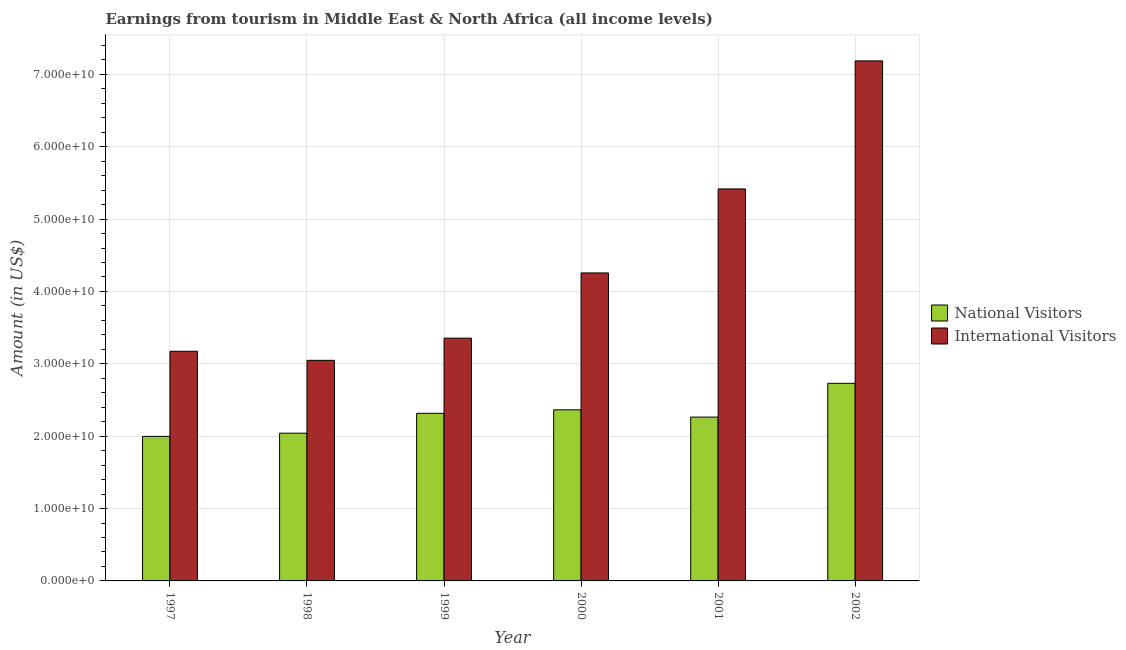How many different coloured bars are there?
Ensure brevity in your answer.  2. How many groups of bars are there?
Provide a short and direct response. 6. Are the number of bars per tick equal to the number of legend labels?
Provide a short and direct response. Yes. How many bars are there on the 4th tick from the left?
Provide a succinct answer. 2. How many bars are there on the 4th tick from the right?
Provide a short and direct response. 2. What is the label of the 5th group of bars from the left?
Give a very brief answer. 2001. What is the amount earned from national visitors in 2002?
Ensure brevity in your answer.  2.73e+1. Across all years, what is the maximum amount earned from national visitors?
Give a very brief answer. 2.73e+1. Across all years, what is the minimum amount earned from national visitors?
Offer a terse response. 2.00e+1. In which year was the amount earned from international visitors minimum?
Make the answer very short. 1998. What is the total amount earned from international visitors in the graph?
Keep it short and to the point. 2.64e+11. What is the difference between the amount earned from national visitors in 2000 and that in 2001?
Keep it short and to the point. 1.00e+09. What is the difference between the amount earned from national visitors in 2001 and the amount earned from international visitors in 1999?
Provide a succinct answer. -5.23e+08. What is the average amount earned from international visitors per year?
Offer a very short reply. 4.41e+1. In the year 2000, what is the difference between the amount earned from national visitors and amount earned from international visitors?
Your answer should be compact. 0. In how many years, is the amount earned from national visitors greater than 60000000000 US$?
Give a very brief answer. 0. What is the ratio of the amount earned from national visitors in 1997 to that in 2000?
Ensure brevity in your answer.  0.84. Is the amount earned from international visitors in 2000 less than that in 2002?
Keep it short and to the point. Yes. What is the difference between the highest and the second highest amount earned from international visitors?
Offer a terse response. 1.77e+1. What is the difference between the highest and the lowest amount earned from international visitors?
Give a very brief answer. 4.14e+1. In how many years, is the amount earned from international visitors greater than the average amount earned from international visitors taken over all years?
Ensure brevity in your answer.  2. What does the 1st bar from the left in 1998 represents?
Make the answer very short. National Visitors. What does the 1st bar from the right in 2002 represents?
Offer a very short reply. International Visitors. Are all the bars in the graph horizontal?
Make the answer very short. No. What is the title of the graph?
Provide a short and direct response. Earnings from tourism in Middle East & North Africa (all income levels). What is the label or title of the X-axis?
Provide a succinct answer. Year. What is the label or title of the Y-axis?
Your answer should be very brief. Amount (in US$). What is the Amount (in US$) of National Visitors in 1997?
Make the answer very short. 2.00e+1. What is the Amount (in US$) of International Visitors in 1997?
Offer a terse response. 3.17e+1. What is the Amount (in US$) in National Visitors in 1998?
Keep it short and to the point. 2.04e+1. What is the Amount (in US$) in International Visitors in 1998?
Provide a succinct answer. 3.05e+1. What is the Amount (in US$) in National Visitors in 1999?
Offer a very short reply. 2.32e+1. What is the Amount (in US$) in International Visitors in 1999?
Your answer should be compact. 3.35e+1. What is the Amount (in US$) of National Visitors in 2000?
Keep it short and to the point. 2.36e+1. What is the Amount (in US$) of International Visitors in 2000?
Make the answer very short. 4.26e+1. What is the Amount (in US$) in National Visitors in 2001?
Ensure brevity in your answer.  2.26e+1. What is the Amount (in US$) in International Visitors in 2001?
Provide a succinct answer. 5.42e+1. What is the Amount (in US$) in National Visitors in 2002?
Your answer should be very brief. 2.73e+1. What is the Amount (in US$) of International Visitors in 2002?
Ensure brevity in your answer.  7.19e+1. Across all years, what is the maximum Amount (in US$) in National Visitors?
Give a very brief answer. 2.73e+1. Across all years, what is the maximum Amount (in US$) of International Visitors?
Provide a short and direct response. 7.19e+1. Across all years, what is the minimum Amount (in US$) in National Visitors?
Offer a very short reply. 2.00e+1. Across all years, what is the minimum Amount (in US$) of International Visitors?
Your answer should be compact. 3.05e+1. What is the total Amount (in US$) of National Visitors in the graph?
Keep it short and to the point. 1.37e+11. What is the total Amount (in US$) of International Visitors in the graph?
Make the answer very short. 2.64e+11. What is the difference between the Amount (in US$) in National Visitors in 1997 and that in 1998?
Give a very brief answer. -4.43e+08. What is the difference between the Amount (in US$) of International Visitors in 1997 and that in 1998?
Offer a very short reply. 1.25e+09. What is the difference between the Amount (in US$) in National Visitors in 1997 and that in 1999?
Ensure brevity in your answer.  -3.19e+09. What is the difference between the Amount (in US$) in International Visitors in 1997 and that in 1999?
Ensure brevity in your answer.  -1.81e+09. What is the difference between the Amount (in US$) of National Visitors in 1997 and that in 2000?
Offer a very short reply. -3.67e+09. What is the difference between the Amount (in US$) of International Visitors in 1997 and that in 2000?
Ensure brevity in your answer.  -1.08e+1. What is the difference between the Amount (in US$) of National Visitors in 1997 and that in 2001?
Provide a short and direct response. -2.67e+09. What is the difference between the Amount (in US$) in International Visitors in 1997 and that in 2001?
Provide a short and direct response. -2.24e+1. What is the difference between the Amount (in US$) in National Visitors in 1997 and that in 2002?
Make the answer very short. -7.33e+09. What is the difference between the Amount (in US$) of International Visitors in 1997 and that in 2002?
Provide a short and direct response. -4.01e+1. What is the difference between the Amount (in US$) of National Visitors in 1998 and that in 1999?
Your response must be concise. -2.75e+09. What is the difference between the Amount (in US$) in International Visitors in 1998 and that in 1999?
Offer a terse response. -3.07e+09. What is the difference between the Amount (in US$) in National Visitors in 1998 and that in 2000?
Ensure brevity in your answer.  -3.23e+09. What is the difference between the Amount (in US$) in International Visitors in 1998 and that in 2000?
Offer a very short reply. -1.21e+1. What is the difference between the Amount (in US$) in National Visitors in 1998 and that in 2001?
Your answer should be compact. -2.22e+09. What is the difference between the Amount (in US$) of International Visitors in 1998 and that in 2001?
Offer a very short reply. -2.37e+1. What is the difference between the Amount (in US$) in National Visitors in 1998 and that in 2002?
Provide a short and direct response. -6.89e+09. What is the difference between the Amount (in US$) of International Visitors in 1998 and that in 2002?
Give a very brief answer. -4.14e+1. What is the difference between the Amount (in US$) in National Visitors in 1999 and that in 2000?
Your response must be concise. -4.79e+08. What is the difference between the Amount (in US$) of International Visitors in 1999 and that in 2000?
Offer a very short reply. -9.01e+09. What is the difference between the Amount (in US$) in National Visitors in 1999 and that in 2001?
Provide a short and direct response. 5.23e+08. What is the difference between the Amount (in US$) of International Visitors in 1999 and that in 2001?
Provide a succinct answer. -2.06e+1. What is the difference between the Amount (in US$) in National Visitors in 1999 and that in 2002?
Make the answer very short. -4.14e+09. What is the difference between the Amount (in US$) in International Visitors in 1999 and that in 2002?
Provide a short and direct response. -3.83e+1. What is the difference between the Amount (in US$) of National Visitors in 2000 and that in 2001?
Offer a terse response. 1.00e+09. What is the difference between the Amount (in US$) in International Visitors in 2000 and that in 2001?
Make the answer very short. -1.16e+1. What is the difference between the Amount (in US$) of National Visitors in 2000 and that in 2002?
Your answer should be compact. -3.66e+09. What is the difference between the Amount (in US$) in International Visitors in 2000 and that in 2002?
Your answer should be compact. -2.93e+1. What is the difference between the Amount (in US$) in National Visitors in 2001 and that in 2002?
Keep it short and to the point. -4.66e+09. What is the difference between the Amount (in US$) of International Visitors in 2001 and that in 2002?
Your answer should be compact. -1.77e+1. What is the difference between the Amount (in US$) of National Visitors in 1997 and the Amount (in US$) of International Visitors in 1998?
Offer a very short reply. -1.05e+1. What is the difference between the Amount (in US$) in National Visitors in 1997 and the Amount (in US$) in International Visitors in 1999?
Ensure brevity in your answer.  -1.36e+1. What is the difference between the Amount (in US$) in National Visitors in 1997 and the Amount (in US$) in International Visitors in 2000?
Ensure brevity in your answer.  -2.26e+1. What is the difference between the Amount (in US$) of National Visitors in 1997 and the Amount (in US$) of International Visitors in 2001?
Provide a short and direct response. -3.42e+1. What is the difference between the Amount (in US$) in National Visitors in 1997 and the Amount (in US$) in International Visitors in 2002?
Your answer should be very brief. -5.19e+1. What is the difference between the Amount (in US$) of National Visitors in 1998 and the Amount (in US$) of International Visitors in 1999?
Offer a very short reply. -1.31e+1. What is the difference between the Amount (in US$) in National Visitors in 1998 and the Amount (in US$) in International Visitors in 2000?
Your response must be concise. -2.21e+1. What is the difference between the Amount (in US$) of National Visitors in 1998 and the Amount (in US$) of International Visitors in 2001?
Ensure brevity in your answer.  -3.38e+1. What is the difference between the Amount (in US$) of National Visitors in 1998 and the Amount (in US$) of International Visitors in 2002?
Keep it short and to the point. -5.14e+1. What is the difference between the Amount (in US$) of National Visitors in 1999 and the Amount (in US$) of International Visitors in 2000?
Keep it short and to the point. -1.94e+1. What is the difference between the Amount (in US$) in National Visitors in 1999 and the Amount (in US$) in International Visitors in 2001?
Your answer should be compact. -3.10e+1. What is the difference between the Amount (in US$) in National Visitors in 1999 and the Amount (in US$) in International Visitors in 2002?
Offer a very short reply. -4.87e+1. What is the difference between the Amount (in US$) of National Visitors in 2000 and the Amount (in US$) of International Visitors in 2001?
Your answer should be very brief. -3.05e+1. What is the difference between the Amount (in US$) of National Visitors in 2000 and the Amount (in US$) of International Visitors in 2002?
Offer a terse response. -4.82e+1. What is the difference between the Amount (in US$) of National Visitors in 2001 and the Amount (in US$) of International Visitors in 2002?
Offer a terse response. -4.92e+1. What is the average Amount (in US$) in National Visitors per year?
Make the answer very short. 2.29e+1. What is the average Amount (in US$) of International Visitors per year?
Offer a terse response. 4.41e+1. In the year 1997, what is the difference between the Amount (in US$) in National Visitors and Amount (in US$) in International Visitors?
Your response must be concise. -1.18e+1. In the year 1998, what is the difference between the Amount (in US$) of National Visitors and Amount (in US$) of International Visitors?
Make the answer very short. -1.01e+1. In the year 1999, what is the difference between the Amount (in US$) of National Visitors and Amount (in US$) of International Visitors?
Keep it short and to the point. -1.04e+1. In the year 2000, what is the difference between the Amount (in US$) in National Visitors and Amount (in US$) in International Visitors?
Keep it short and to the point. -1.89e+1. In the year 2001, what is the difference between the Amount (in US$) of National Visitors and Amount (in US$) of International Visitors?
Ensure brevity in your answer.  -3.15e+1. In the year 2002, what is the difference between the Amount (in US$) in National Visitors and Amount (in US$) in International Visitors?
Offer a very short reply. -4.46e+1. What is the ratio of the Amount (in US$) of National Visitors in 1997 to that in 1998?
Provide a succinct answer. 0.98. What is the ratio of the Amount (in US$) of International Visitors in 1997 to that in 1998?
Provide a succinct answer. 1.04. What is the ratio of the Amount (in US$) in National Visitors in 1997 to that in 1999?
Ensure brevity in your answer.  0.86. What is the ratio of the Amount (in US$) in International Visitors in 1997 to that in 1999?
Keep it short and to the point. 0.95. What is the ratio of the Amount (in US$) in National Visitors in 1997 to that in 2000?
Make the answer very short. 0.84. What is the ratio of the Amount (in US$) in International Visitors in 1997 to that in 2000?
Keep it short and to the point. 0.75. What is the ratio of the Amount (in US$) in National Visitors in 1997 to that in 2001?
Make the answer very short. 0.88. What is the ratio of the Amount (in US$) in International Visitors in 1997 to that in 2001?
Offer a terse response. 0.59. What is the ratio of the Amount (in US$) in National Visitors in 1997 to that in 2002?
Give a very brief answer. 0.73. What is the ratio of the Amount (in US$) in International Visitors in 1997 to that in 2002?
Your answer should be compact. 0.44. What is the ratio of the Amount (in US$) of National Visitors in 1998 to that in 1999?
Your answer should be very brief. 0.88. What is the ratio of the Amount (in US$) of International Visitors in 1998 to that in 1999?
Make the answer very short. 0.91. What is the ratio of the Amount (in US$) in National Visitors in 1998 to that in 2000?
Your response must be concise. 0.86. What is the ratio of the Amount (in US$) in International Visitors in 1998 to that in 2000?
Ensure brevity in your answer.  0.72. What is the ratio of the Amount (in US$) in National Visitors in 1998 to that in 2001?
Your answer should be compact. 0.9. What is the ratio of the Amount (in US$) of International Visitors in 1998 to that in 2001?
Ensure brevity in your answer.  0.56. What is the ratio of the Amount (in US$) in National Visitors in 1998 to that in 2002?
Your answer should be compact. 0.75. What is the ratio of the Amount (in US$) of International Visitors in 1998 to that in 2002?
Ensure brevity in your answer.  0.42. What is the ratio of the Amount (in US$) in National Visitors in 1999 to that in 2000?
Offer a terse response. 0.98. What is the ratio of the Amount (in US$) in International Visitors in 1999 to that in 2000?
Ensure brevity in your answer.  0.79. What is the ratio of the Amount (in US$) in National Visitors in 1999 to that in 2001?
Make the answer very short. 1.02. What is the ratio of the Amount (in US$) of International Visitors in 1999 to that in 2001?
Keep it short and to the point. 0.62. What is the ratio of the Amount (in US$) in National Visitors in 1999 to that in 2002?
Make the answer very short. 0.85. What is the ratio of the Amount (in US$) in International Visitors in 1999 to that in 2002?
Provide a short and direct response. 0.47. What is the ratio of the Amount (in US$) of National Visitors in 2000 to that in 2001?
Your response must be concise. 1.04. What is the ratio of the Amount (in US$) of International Visitors in 2000 to that in 2001?
Keep it short and to the point. 0.79. What is the ratio of the Amount (in US$) of National Visitors in 2000 to that in 2002?
Give a very brief answer. 0.87. What is the ratio of the Amount (in US$) in International Visitors in 2000 to that in 2002?
Ensure brevity in your answer.  0.59. What is the ratio of the Amount (in US$) in National Visitors in 2001 to that in 2002?
Give a very brief answer. 0.83. What is the ratio of the Amount (in US$) in International Visitors in 2001 to that in 2002?
Give a very brief answer. 0.75. What is the difference between the highest and the second highest Amount (in US$) in National Visitors?
Your answer should be very brief. 3.66e+09. What is the difference between the highest and the second highest Amount (in US$) in International Visitors?
Offer a terse response. 1.77e+1. What is the difference between the highest and the lowest Amount (in US$) in National Visitors?
Keep it short and to the point. 7.33e+09. What is the difference between the highest and the lowest Amount (in US$) in International Visitors?
Keep it short and to the point. 4.14e+1. 